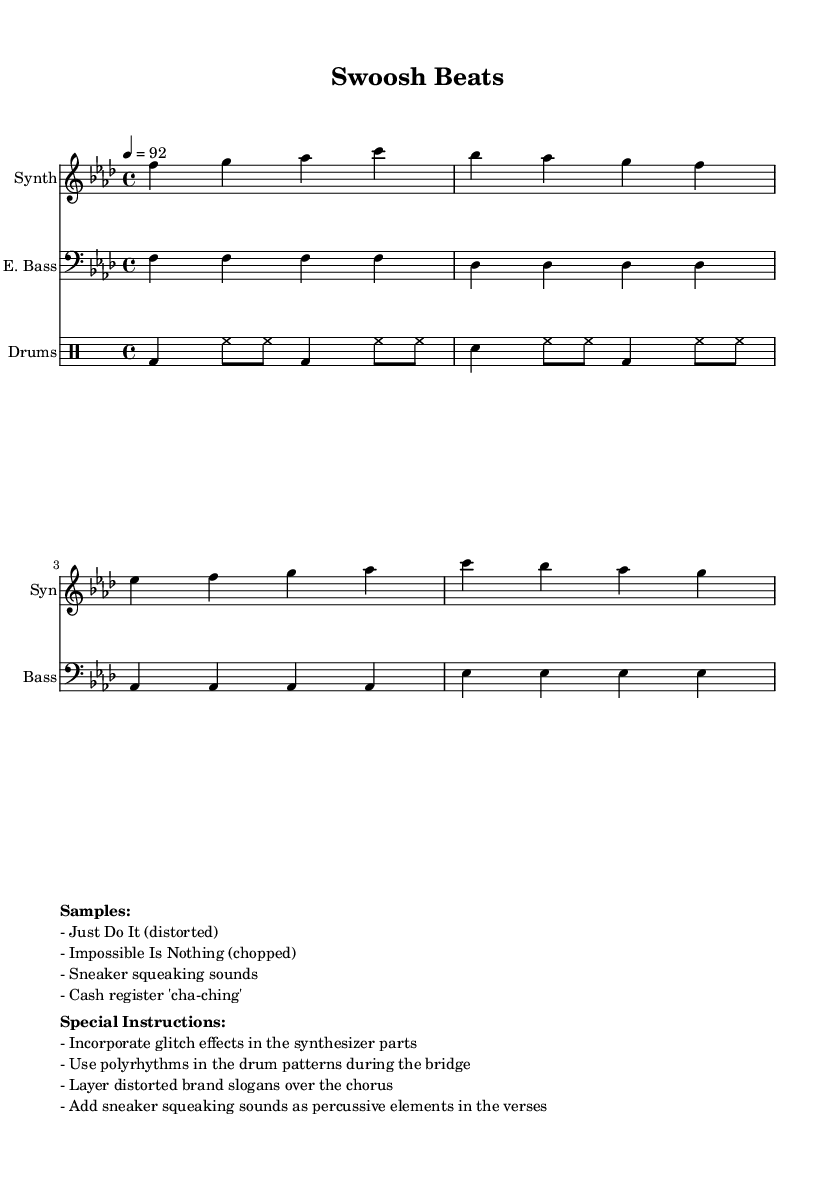What is the key signature of this music? The key signature is indicated at the beginning of the music sheet. It has four flats, which corresponds to F minor.
Answer: F minor What is the time signature of this music? The time signature is placed after the key signature at the beginning of the music sheet. It is displayed as 4/4, meaning there are four beats per measure, and quarter notes get one beat.
Answer: 4/4 What is the tempo marking of this piece? The tempo is specified using a number and symbol indicating beats per minute. It is marked as quarter note equals 92, which means there are 92 quarter notes played in one minute.
Answer: 92 What is the instrument that plays the synthesized melody? The instrument is listed in the staff header, which indicates that the synth part is assigned to a "Synth" instrument.
Answer: Synth How many measures are in the synth melody? By counting the individual groups of notes and bars, it can be found that the synth melody consists of four measures.
Answer: 4 What sound effects are specified in the special instructions? The special instructions list certain sounds to be incorporated into the piece. These include glitch effects and sneaker squeaking sounds among others.
Answer: Glitch effects What distinct samples are mentioned in the score? The samples are represented in a section marked "Samples," where specific distorted and chopped slogans are noted. This includes "Just Do It (distorted)" and "Impossible Is Nothing (chopped)."
Answer: Just Do It (distorted) 